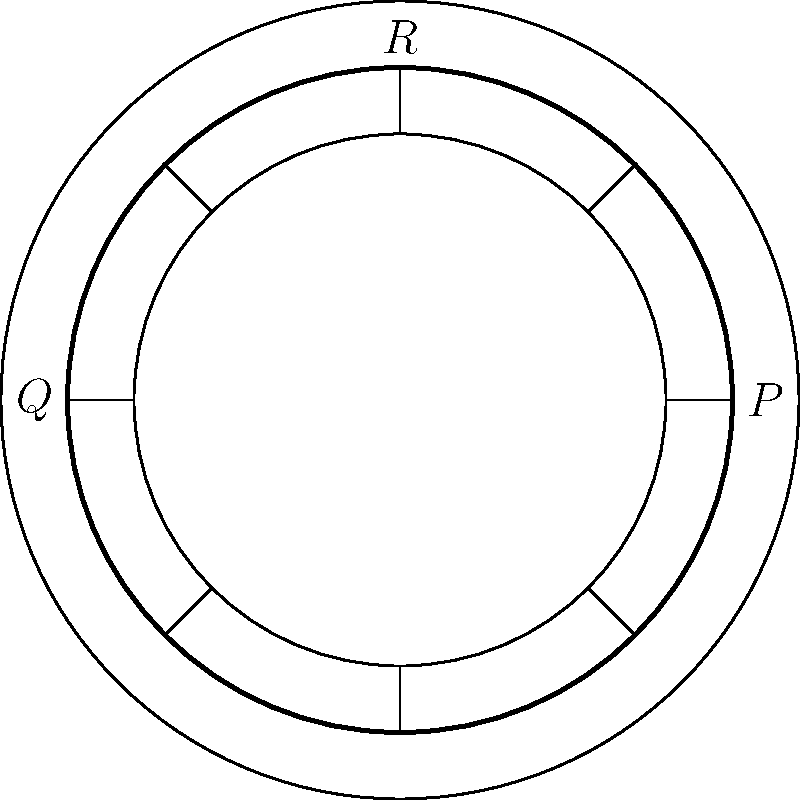In the hyperbolic plane represented by this Native American drum-like pattern, consider the three points P, Q, and R on the outer circle. If the sum of the interior angles of the triangle PQR is less than 180°, what does this imply about the curvature of the space? To understand the curvature of space on a hyperbolic plane, we need to consider the following steps:

1. In Euclidean geometry, the sum of interior angles of a triangle is always 180°.

2. In non-Euclidean geometry, this sum can differ from 180°:
   - In spherical geometry (positive curvature), the sum is greater than 180°.
   - In hyperbolic geometry (negative curvature), the sum is less than 180°.

3. The question states that the sum of interior angles of triangle PQR is less than 180°.

4. This property is characteristic of hyperbolic geometry.

5. In hyperbolic geometry, the space has a constant negative curvature.

6. The Native American drum-like pattern in the image is reminiscent of the Poincaré disk model, which is one way to represent hyperbolic geometry in a finite area.

7. In this model, straight lines appear as circular arcs perpendicular to the boundary circle, and angles are measured in the usual Euclidean sense.

8. The fact that the sum of angles is less than 180° implies that the space curves away from itself at every point, creating a saddle-like shape.

Therefore, the sum of interior angles being less than 180° implies that the space has negative curvature, which is characteristic of hyperbolic geometry.
Answer: Negative curvature 